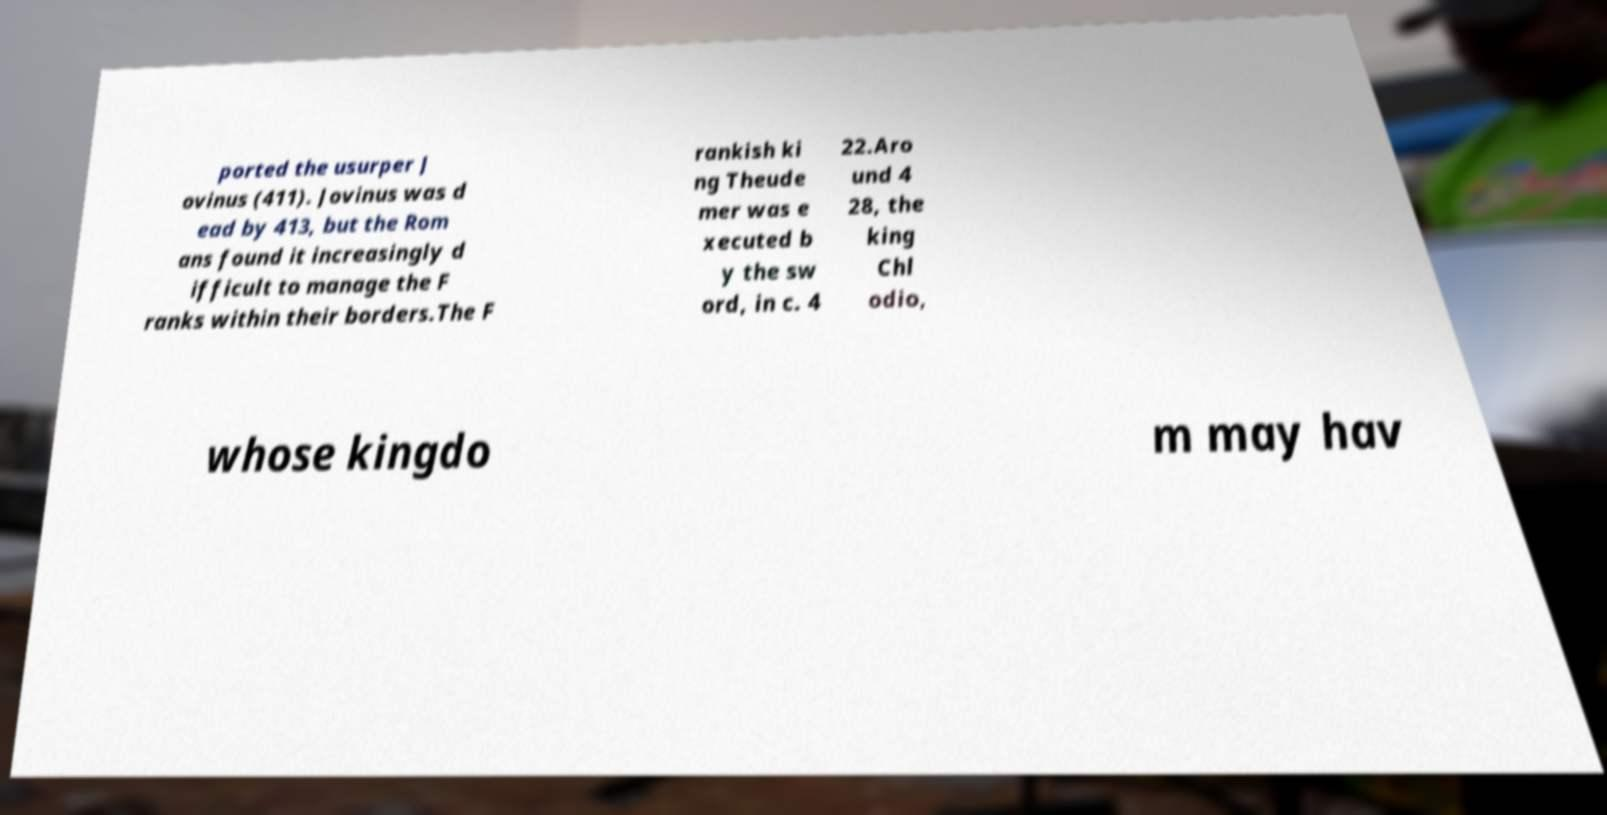Can you read and provide the text displayed in the image?This photo seems to have some interesting text. Can you extract and type it out for me? ported the usurper J ovinus (411). Jovinus was d ead by 413, but the Rom ans found it increasingly d ifficult to manage the F ranks within their borders.The F rankish ki ng Theude mer was e xecuted b y the sw ord, in c. 4 22.Aro und 4 28, the king Chl odio, whose kingdo m may hav 